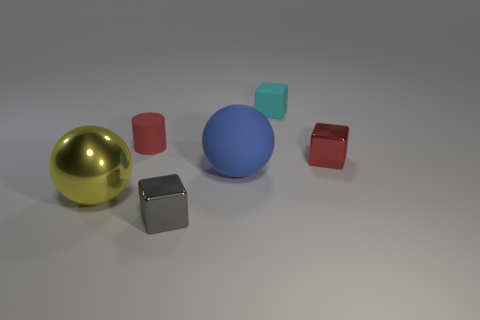Add 3 matte spheres. How many objects exist? 9 Subtract all balls. How many objects are left? 4 Subtract all tiny blue balls. Subtract all small gray objects. How many objects are left? 5 Add 1 small objects. How many small objects are left? 5 Add 1 tiny red metallic cubes. How many tiny red metallic cubes exist? 2 Subtract 0 blue blocks. How many objects are left? 6 